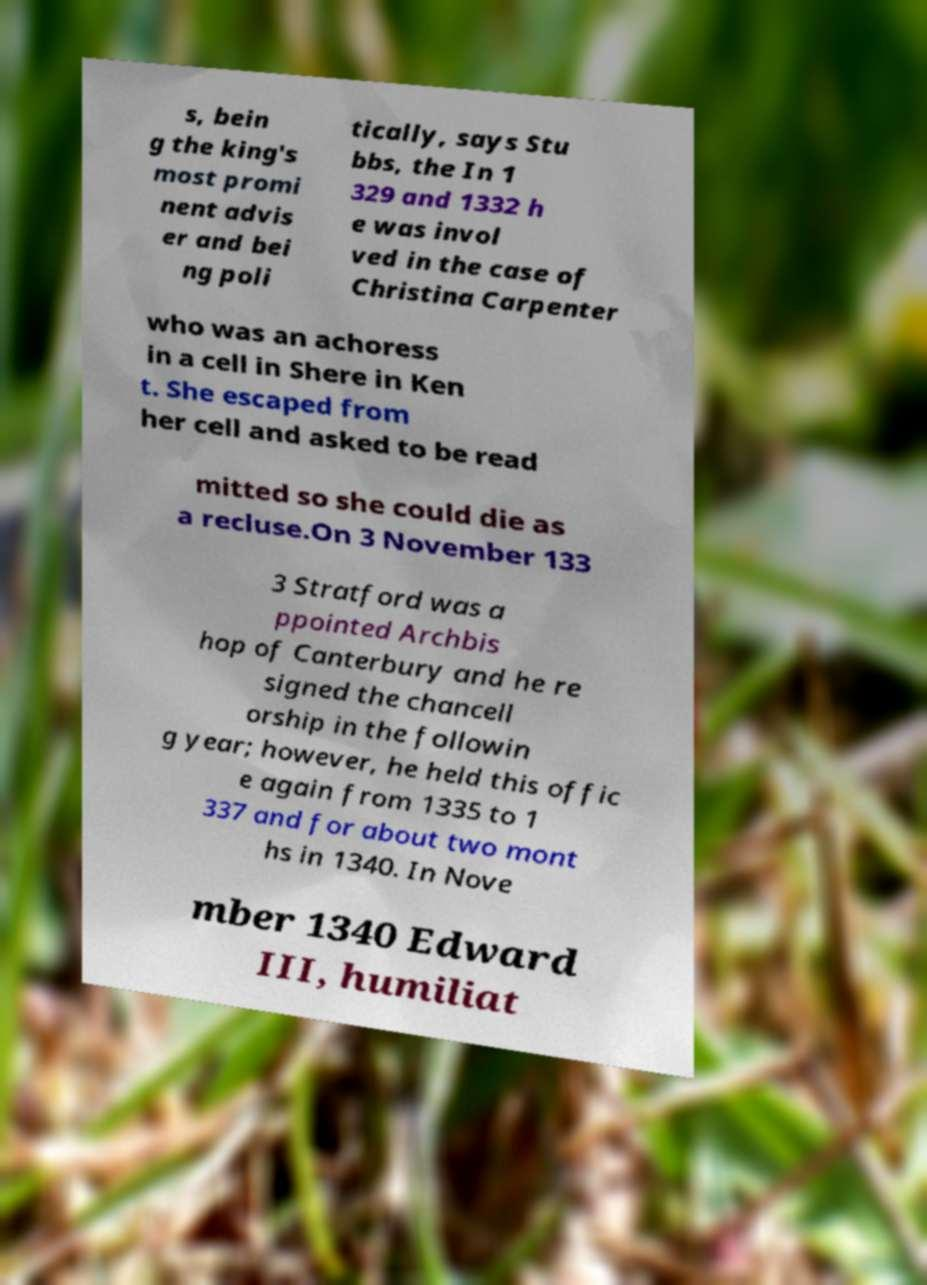Can you read and provide the text displayed in the image?This photo seems to have some interesting text. Can you extract and type it out for me? s, bein g the king's most promi nent advis er and bei ng poli tically, says Stu bbs, the In 1 329 and 1332 h e was invol ved in the case of Christina Carpenter who was an achoress in a cell in Shere in Ken t. She escaped from her cell and asked to be read mitted so she could die as a recluse.On 3 November 133 3 Stratford was a ppointed Archbis hop of Canterbury and he re signed the chancell orship in the followin g year; however, he held this offic e again from 1335 to 1 337 and for about two mont hs in 1340. In Nove mber 1340 Edward III, humiliat 